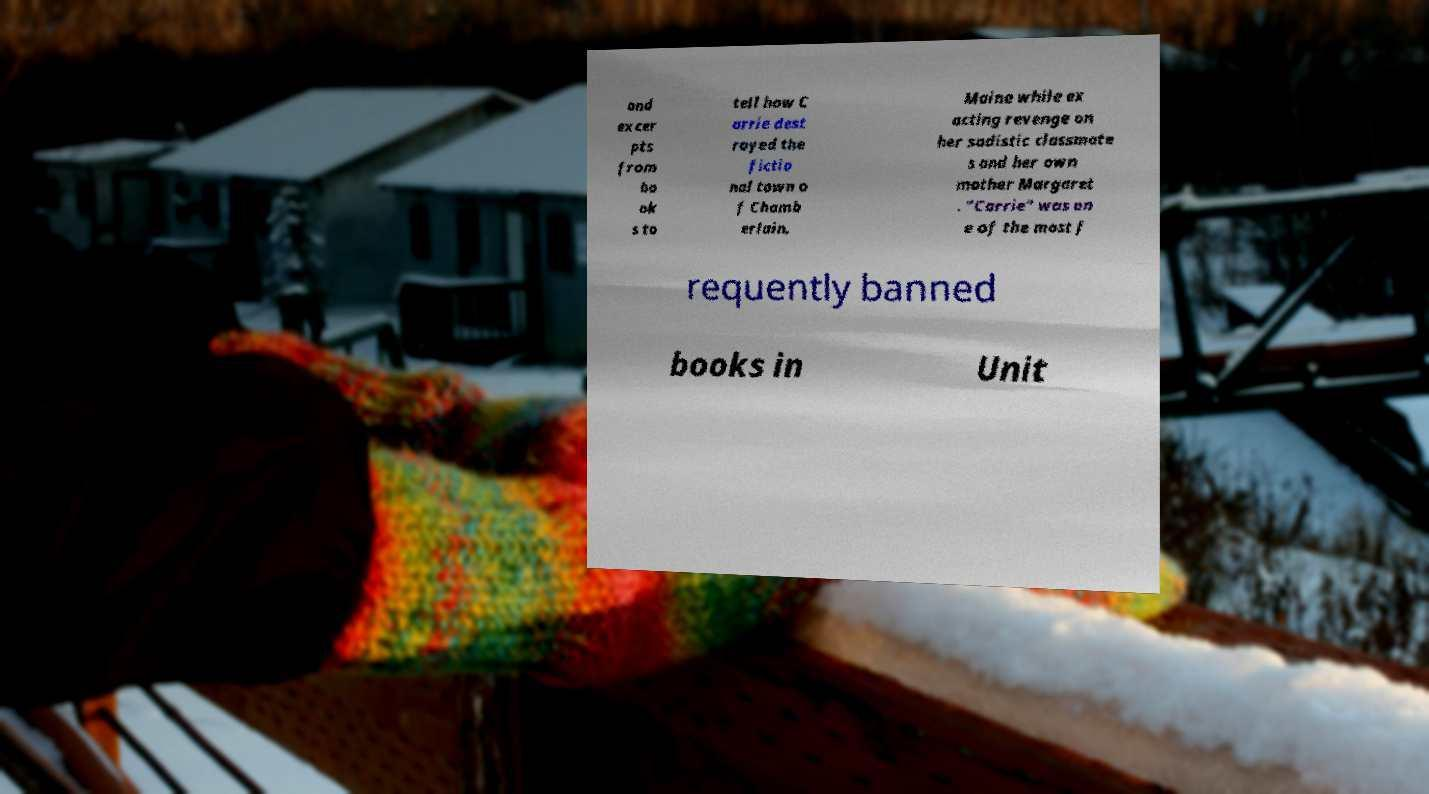Could you extract and type out the text from this image? and excer pts from bo ok s to tell how C arrie dest royed the fictio nal town o f Chamb erlain, Maine while ex acting revenge on her sadistic classmate s and her own mother Margaret . "Carrie" was on e of the most f requently banned books in Unit 